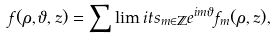<formula> <loc_0><loc_0><loc_500><loc_500>f ( \rho , \vartheta , z ) = \sum \lim i t s _ { m \in \mathbb { Z } } e ^ { i m \vartheta } f _ { m } ( \rho , z ) ,</formula> 